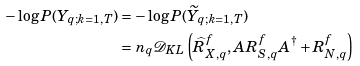<formula> <loc_0><loc_0><loc_500><loc_500>- \log P ( Y _ { q ; k = 1 , T } ) & = - \log P ( \widetilde { Y } _ { q ; k = 1 , T } ) \\ & = n _ { q } \mathcal { D } _ { K L } \left ( \widehat { R } _ { X , q } ^ { f } , A R _ { S , q } ^ { f } A ^ { \dagger } + R _ { N , q } ^ { f } \right )</formula> 